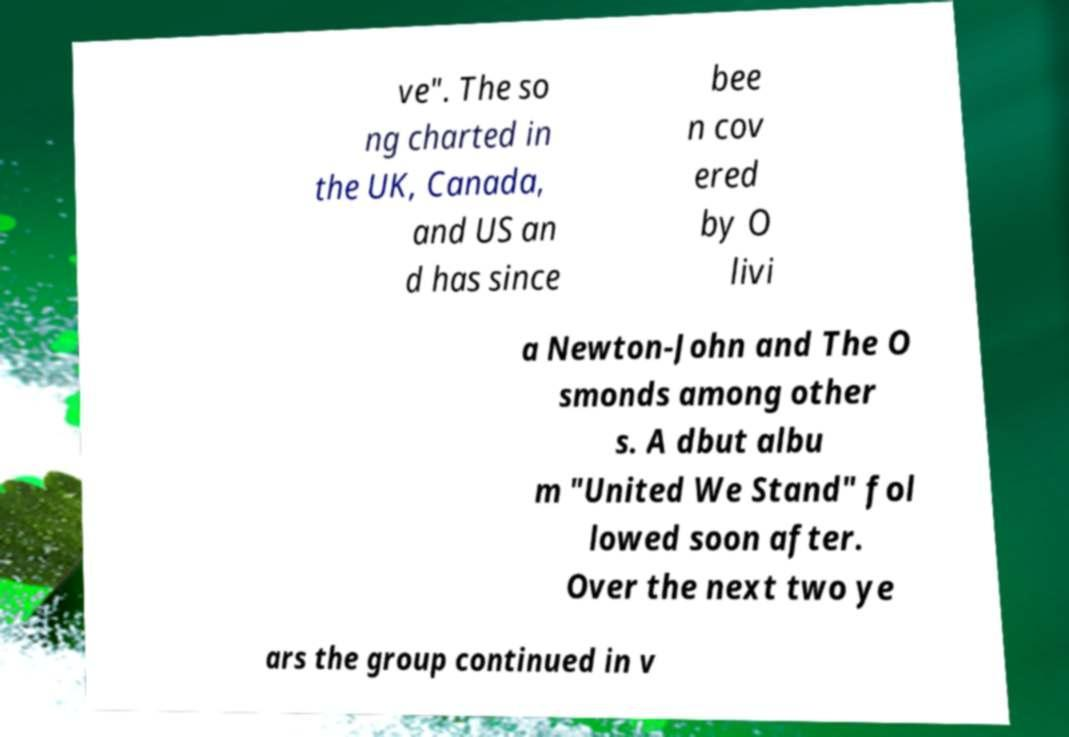For documentation purposes, I need the text within this image transcribed. Could you provide that? ve". The so ng charted in the UK, Canada, and US an d has since bee n cov ered by O livi a Newton-John and The O smonds among other s. A dbut albu m "United We Stand" fol lowed soon after. Over the next two ye ars the group continued in v 